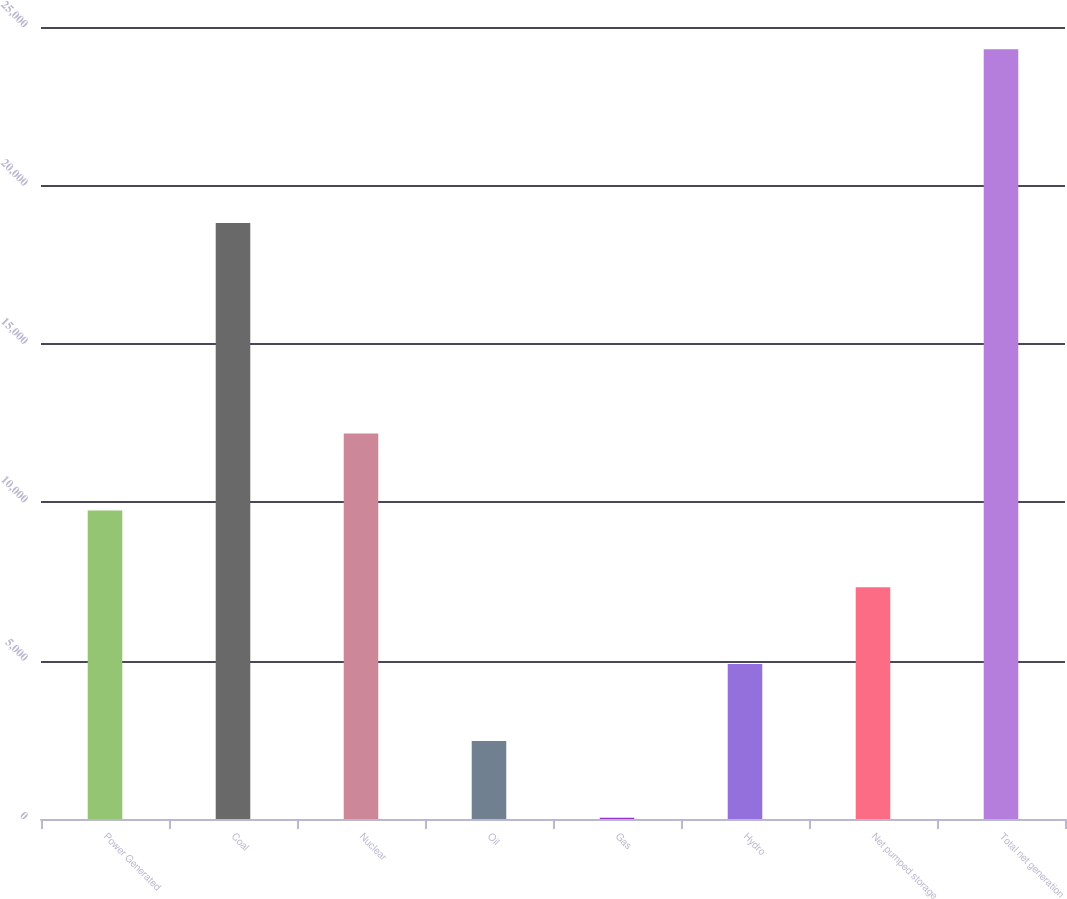<chart> <loc_0><loc_0><loc_500><loc_500><bar_chart><fcel>Power Generated<fcel>Coal<fcel>Nuclear<fcel>Oil<fcel>Gas<fcel>Hydro<fcel>Net pumped storage<fcel>Total net generation<nl><fcel>9740.4<fcel>18810<fcel>12166<fcel>2463.6<fcel>38<fcel>4889.2<fcel>7314.8<fcel>24294<nl></chart> 